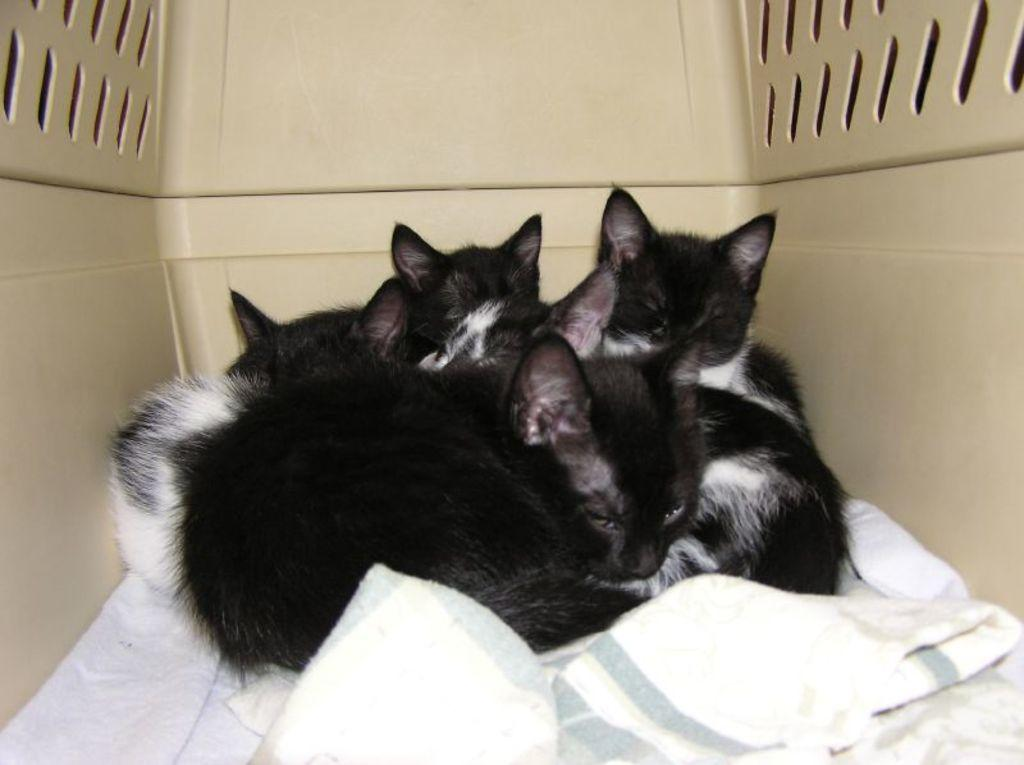What type of animals are in the image? There are cats in the image. What else can be seen in the image besides the cats? There is a cloth and a box-like object in the image. Can you see a monkey playing with a shoe in the image? No, there is no monkey or shoe present in the image. 